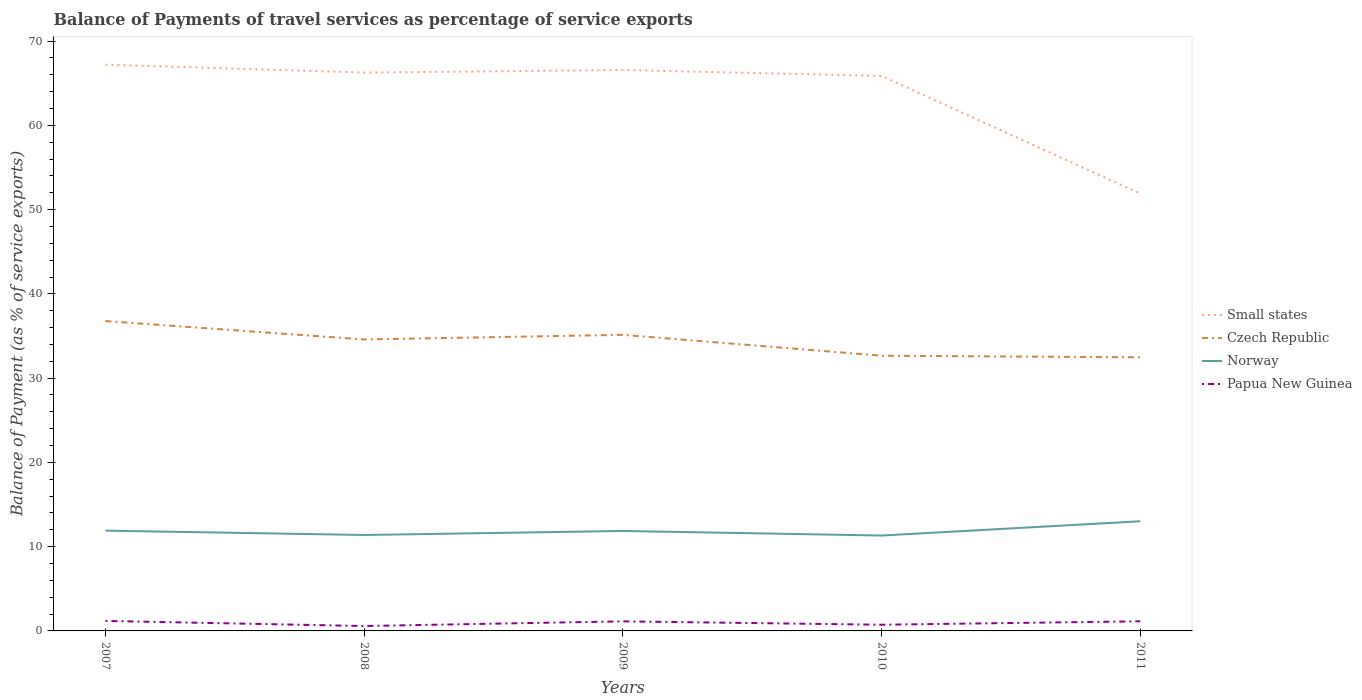Does the line corresponding to Czech Republic intersect with the line corresponding to Papua New Guinea?
Offer a very short reply. No. Across all years, what is the maximum balance of payments of travel services in Small states?
Provide a succinct answer. 51.89. In which year was the balance of payments of travel services in Small states maximum?
Your response must be concise. 2011. What is the total balance of payments of travel services in Norway in the graph?
Offer a very short reply. -1.7. What is the difference between the highest and the second highest balance of payments of travel services in Czech Republic?
Your response must be concise. 4.3. Is the balance of payments of travel services in Small states strictly greater than the balance of payments of travel services in Czech Republic over the years?
Keep it short and to the point. No. How many years are there in the graph?
Provide a short and direct response. 5. Does the graph contain grids?
Offer a very short reply. No. Where does the legend appear in the graph?
Keep it short and to the point. Center right. How many legend labels are there?
Provide a succinct answer. 4. What is the title of the graph?
Your answer should be very brief. Balance of Payments of travel services as percentage of service exports. Does "Macao" appear as one of the legend labels in the graph?
Your answer should be very brief. No. What is the label or title of the Y-axis?
Provide a short and direct response. Balance of Payment (as % of service exports). What is the Balance of Payment (as % of service exports) of Small states in 2007?
Make the answer very short. 67.21. What is the Balance of Payment (as % of service exports) of Czech Republic in 2007?
Offer a very short reply. 36.77. What is the Balance of Payment (as % of service exports) of Norway in 2007?
Make the answer very short. 11.9. What is the Balance of Payment (as % of service exports) in Papua New Guinea in 2007?
Ensure brevity in your answer.  1.19. What is the Balance of Payment (as % of service exports) in Small states in 2008?
Make the answer very short. 66.26. What is the Balance of Payment (as % of service exports) of Czech Republic in 2008?
Offer a very short reply. 34.59. What is the Balance of Payment (as % of service exports) of Norway in 2008?
Make the answer very short. 11.38. What is the Balance of Payment (as % of service exports) of Papua New Guinea in 2008?
Keep it short and to the point. 0.58. What is the Balance of Payment (as % of service exports) of Small states in 2009?
Your answer should be very brief. 66.57. What is the Balance of Payment (as % of service exports) in Czech Republic in 2009?
Your response must be concise. 35.14. What is the Balance of Payment (as % of service exports) of Norway in 2009?
Make the answer very short. 11.86. What is the Balance of Payment (as % of service exports) of Papua New Guinea in 2009?
Offer a very short reply. 1.14. What is the Balance of Payment (as % of service exports) in Small states in 2010?
Provide a short and direct response. 65.87. What is the Balance of Payment (as % of service exports) of Czech Republic in 2010?
Offer a terse response. 32.66. What is the Balance of Payment (as % of service exports) in Norway in 2010?
Offer a very short reply. 11.32. What is the Balance of Payment (as % of service exports) in Papua New Guinea in 2010?
Give a very brief answer. 0.73. What is the Balance of Payment (as % of service exports) of Small states in 2011?
Your answer should be very brief. 51.89. What is the Balance of Payment (as % of service exports) of Czech Republic in 2011?
Offer a terse response. 32.47. What is the Balance of Payment (as % of service exports) in Norway in 2011?
Your response must be concise. 13.01. What is the Balance of Payment (as % of service exports) in Papua New Guinea in 2011?
Provide a succinct answer. 1.14. Across all years, what is the maximum Balance of Payment (as % of service exports) of Small states?
Offer a terse response. 67.21. Across all years, what is the maximum Balance of Payment (as % of service exports) in Czech Republic?
Keep it short and to the point. 36.77. Across all years, what is the maximum Balance of Payment (as % of service exports) of Norway?
Ensure brevity in your answer.  13.01. Across all years, what is the maximum Balance of Payment (as % of service exports) in Papua New Guinea?
Offer a terse response. 1.19. Across all years, what is the minimum Balance of Payment (as % of service exports) of Small states?
Your answer should be compact. 51.89. Across all years, what is the minimum Balance of Payment (as % of service exports) of Czech Republic?
Offer a very short reply. 32.47. Across all years, what is the minimum Balance of Payment (as % of service exports) of Norway?
Provide a short and direct response. 11.32. Across all years, what is the minimum Balance of Payment (as % of service exports) in Papua New Guinea?
Keep it short and to the point. 0.58. What is the total Balance of Payment (as % of service exports) in Small states in the graph?
Provide a short and direct response. 317.8. What is the total Balance of Payment (as % of service exports) of Czech Republic in the graph?
Provide a short and direct response. 171.64. What is the total Balance of Payment (as % of service exports) of Norway in the graph?
Your answer should be compact. 59.49. What is the total Balance of Payment (as % of service exports) of Papua New Guinea in the graph?
Offer a very short reply. 4.78. What is the difference between the Balance of Payment (as % of service exports) in Small states in 2007 and that in 2008?
Ensure brevity in your answer.  0.94. What is the difference between the Balance of Payment (as % of service exports) in Czech Republic in 2007 and that in 2008?
Your answer should be compact. 2.18. What is the difference between the Balance of Payment (as % of service exports) of Norway in 2007 and that in 2008?
Keep it short and to the point. 0.52. What is the difference between the Balance of Payment (as % of service exports) of Papua New Guinea in 2007 and that in 2008?
Your answer should be very brief. 0.6. What is the difference between the Balance of Payment (as % of service exports) of Small states in 2007 and that in 2009?
Provide a succinct answer. 0.64. What is the difference between the Balance of Payment (as % of service exports) of Czech Republic in 2007 and that in 2009?
Give a very brief answer. 1.63. What is the difference between the Balance of Payment (as % of service exports) of Norway in 2007 and that in 2009?
Your answer should be compact. 0.04. What is the difference between the Balance of Payment (as % of service exports) in Papua New Guinea in 2007 and that in 2009?
Offer a terse response. 0.05. What is the difference between the Balance of Payment (as % of service exports) of Small states in 2007 and that in 2010?
Keep it short and to the point. 1.34. What is the difference between the Balance of Payment (as % of service exports) of Czech Republic in 2007 and that in 2010?
Offer a very short reply. 4.11. What is the difference between the Balance of Payment (as % of service exports) in Norway in 2007 and that in 2010?
Keep it short and to the point. 0.59. What is the difference between the Balance of Payment (as % of service exports) of Papua New Guinea in 2007 and that in 2010?
Make the answer very short. 0.45. What is the difference between the Balance of Payment (as % of service exports) of Small states in 2007 and that in 2011?
Provide a succinct answer. 15.31. What is the difference between the Balance of Payment (as % of service exports) of Czech Republic in 2007 and that in 2011?
Your answer should be very brief. 4.3. What is the difference between the Balance of Payment (as % of service exports) in Norway in 2007 and that in 2011?
Your response must be concise. -1.11. What is the difference between the Balance of Payment (as % of service exports) of Papua New Guinea in 2007 and that in 2011?
Offer a very short reply. 0.04. What is the difference between the Balance of Payment (as % of service exports) in Small states in 2008 and that in 2009?
Provide a short and direct response. -0.31. What is the difference between the Balance of Payment (as % of service exports) in Czech Republic in 2008 and that in 2009?
Give a very brief answer. -0.55. What is the difference between the Balance of Payment (as % of service exports) in Norway in 2008 and that in 2009?
Make the answer very short. -0.48. What is the difference between the Balance of Payment (as % of service exports) in Papua New Guinea in 2008 and that in 2009?
Offer a very short reply. -0.55. What is the difference between the Balance of Payment (as % of service exports) in Small states in 2008 and that in 2010?
Provide a short and direct response. 0.4. What is the difference between the Balance of Payment (as % of service exports) of Czech Republic in 2008 and that in 2010?
Your answer should be compact. 1.93. What is the difference between the Balance of Payment (as % of service exports) in Norway in 2008 and that in 2010?
Give a very brief answer. 0.07. What is the difference between the Balance of Payment (as % of service exports) of Papua New Guinea in 2008 and that in 2010?
Offer a terse response. -0.15. What is the difference between the Balance of Payment (as % of service exports) in Small states in 2008 and that in 2011?
Give a very brief answer. 14.37. What is the difference between the Balance of Payment (as % of service exports) in Czech Republic in 2008 and that in 2011?
Offer a terse response. 2.12. What is the difference between the Balance of Payment (as % of service exports) of Norway in 2008 and that in 2011?
Provide a short and direct response. -1.63. What is the difference between the Balance of Payment (as % of service exports) of Papua New Guinea in 2008 and that in 2011?
Provide a short and direct response. -0.56. What is the difference between the Balance of Payment (as % of service exports) of Small states in 2009 and that in 2010?
Your answer should be very brief. 0.71. What is the difference between the Balance of Payment (as % of service exports) of Czech Republic in 2009 and that in 2010?
Make the answer very short. 2.48. What is the difference between the Balance of Payment (as % of service exports) of Norway in 2009 and that in 2010?
Offer a terse response. 0.54. What is the difference between the Balance of Payment (as % of service exports) of Papua New Guinea in 2009 and that in 2010?
Ensure brevity in your answer.  0.4. What is the difference between the Balance of Payment (as % of service exports) of Small states in 2009 and that in 2011?
Make the answer very short. 14.68. What is the difference between the Balance of Payment (as % of service exports) of Czech Republic in 2009 and that in 2011?
Provide a succinct answer. 2.67. What is the difference between the Balance of Payment (as % of service exports) of Norway in 2009 and that in 2011?
Provide a succinct answer. -1.15. What is the difference between the Balance of Payment (as % of service exports) in Papua New Guinea in 2009 and that in 2011?
Offer a terse response. -0.01. What is the difference between the Balance of Payment (as % of service exports) in Small states in 2010 and that in 2011?
Keep it short and to the point. 13.97. What is the difference between the Balance of Payment (as % of service exports) in Czech Republic in 2010 and that in 2011?
Give a very brief answer. 0.19. What is the difference between the Balance of Payment (as % of service exports) of Norway in 2010 and that in 2011?
Offer a terse response. -1.7. What is the difference between the Balance of Payment (as % of service exports) in Papua New Guinea in 2010 and that in 2011?
Offer a very short reply. -0.41. What is the difference between the Balance of Payment (as % of service exports) in Small states in 2007 and the Balance of Payment (as % of service exports) in Czech Republic in 2008?
Give a very brief answer. 32.62. What is the difference between the Balance of Payment (as % of service exports) of Small states in 2007 and the Balance of Payment (as % of service exports) of Norway in 2008?
Make the answer very short. 55.82. What is the difference between the Balance of Payment (as % of service exports) of Small states in 2007 and the Balance of Payment (as % of service exports) of Papua New Guinea in 2008?
Your response must be concise. 66.62. What is the difference between the Balance of Payment (as % of service exports) of Czech Republic in 2007 and the Balance of Payment (as % of service exports) of Norway in 2008?
Make the answer very short. 25.39. What is the difference between the Balance of Payment (as % of service exports) in Czech Republic in 2007 and the Balance of Payment (as % of service exports) in Papua New Guinea in 2008?
Ensure brevity in your answer.  36.19. What is the difference between the Balance of Payment (as % of service exports) of Norway in 2007 and the Balance of Payment (as % of service exports) of Papua New Guinea in 2008?
Give a very brief answer. 11.32. What is the difference between the Balance of Payment (as % of service exports) of Small states in 2007 and the Balance of Payment (as % of service exports) of Czech Republic in 2009?
Offer a very short reply. 32.07. What is the difference between the Balance of Payment (as % of service exports) of Small states in 2007 and the Balance of Payment (as % of service exports) of Norway in 2009?
Your response must be concise. 55.34. What is the difference between the Balance of Payment (as % of service exports) of Small states in 2007 and the Balance of Payment (as % of service exports) of Papua New Guinea in 2009?
Provide a succinct answer. 66.07. What is the difference between the Balance of Payment (as % of service exports) in Czech Republic in 2007 and the Balance of Payment (as % of service exports) in Norway in 2009?
Give a very brief answer. 24.91. What is the difference between the Balance of Payment (as % of service exports) in Czech Republic in 2007 and the Balance of Payment (as % of service exports) in Papua New Guinea in 2009?
Your response must be concise. 35.64. What is the difference between the Balance of Payment (as % of service exports) of Norway in 2007 and the Balance of Payment (as % of service exports) of Papua New Guinea in 2009?
Offer a very short reply. 10.77. What is the difference between the Balance of Payment (as % of service exports) of Small states in 2007 and the Balance of Payment (as % of service exports) of Czech Republic in 2010?
Offer a very short reply. 34.54. What is the difference between the Balance of Payment (as % of service exports) in Small states in 2007 and the Balance of Payment (as % of service exports) in Norway in 2010?
Your answer should be very brief. 55.89. What is the difference between the Balance of Payment (as % of service exports) in Small states in 2007 and the Balance of Payment (as % of service exports) in Papua New Guinea in 2010?
Provide a short and direct response. 66.47. What is the difference between the Balance of Payment (as % of service exports) in Czech Republic in 2007 and the Balance of Payment (as % of service exports) in Norway in 2010?
Offer a very short reply. 25.46. What is the difference between the Balance of Payment (as % of service exports) in Czech Republic in 2007 and the Balance of Payment (as % of service exports) in Papua New Guinea in 2010?
Provide a succinct answer. 36.04. What is the difference between the Balance of Payment (as % of service exports) in Norway in 2007 and the Balance of Payment (as % of service exports) in Papua New Guinea in 2010?
Your answer should be very brief. 11.17. What is the difference between the Balance of Payment (as % of service exports) in Small states in 2007 and the Balance of Payment (as % of service exports) in Czech Republic in 2011?
Provide a short and direct response. 34.73. What is the difference between the Balance of Payment (as % of service exports) of Small states in 2007 and the Balance of Payment (as % of service exports) of Norway in 2011?
Your answer should be very brief. 54.19. What is the difference between the Balance of Payment (as % of service exports) in Small states in 2007 and the Balance of Payment (as % of service exports) in Papua New Guinea in 2011?
Offer a very short reply. 66.06. What is the difference between the Balance of Payment (as % of service exports) in Czech Republic in 2007 and the Balance of Payment (as % of service exports) in Norway in 2011?
Your answer should be very brief. 23.76. What is the difference between the Balance of Payment (as % of service exports) in Czech Republic in 2007 and the Balance of Payment (as % of service exports) in Papua New Guinea in 2011?
Offer a very short reply. 35.63. What is the difference between the Balance of Payment (as % of service exports) in Norway in 2007 and the Balance of Payment (as % of service exports) in Papua New Guinea in 2011?
Your response must be concise. 10.76. What is the difference between the Balance of Payment (as % of service exports) in Small states in 2008 and the Balance of Payment (as % of service exports) in Czech Republic in 2009?
Your response must be concise. 31.12. What is the difference between the Balance of Payment (as % of service exports) of Small states in 2008 and the Balance of Payment (as % of service exports) of Norway in 2009?
Provide a succinct answer. 54.4. What is the difference between the Balance of Payment (as % of service exports) of Small states in 2008 and the Balance of Payment (as % of service exports) of Papua New Guinea in 2009?
Your answer should be very brief. 65.13. What is the difference between the Balance of Payment (as % of service exports) of Czech Republic in 2008 and the Balance of Payment (as % of service exports) of Norway in 2009?
Your answer should be very brief. 22.73. What is the difference between the Balance of Payment (as % of service exports) in Czech Republic in 2008 and the Balance of Payment (as % of service exports) in Papua New Guinea in 2009?
Keep it short and to the point. 33.46. What is the difference between the Balance of Payment (as % of service exports) in Norway in 2008 and the Balance of Payment (as % of service exports) in Papua New Guinea in 2009?
Your answer should be compact. 10.25. What is the difference between the Balance of Payment (as % of service exports) in Small states in 2008 and the Balance of Payment (as % of service exports) in Czech Republic in 2010?
Offer a terse response. 33.6. What is the difference between the Balance of Payment (as % of service exports) in Small states in 2008 and the Balance of Payment (as % of service exports) in Norway in 2010?
Make the answer very short. 54.94. What is the difference between the Balance of Payment (as % of service exports) in Small states in 2008 and the Balance of Payment (as % of service exports) in Papua New Guinea in 2010?
Provide a short and direct response. 65.53. What is the difference between the Balance of Payment (as % of service exports) in Czech Republic in 2008 and the Balance of Payment (as % of service exports) in Norway in 2010?
Offer a very short reply. 23.27. What is the difference between the Balance of Payment (as % of service exports) in Czech Republic in 2008 and the Balance of Payment (as % of service exports) in Papua New Guinea in 2010?
Your answer should be very brief. 33.86. What is the difference between the Balance of Payment (as % of service exports) in Norway in 2008 and the Balance of Payment (as % of service exports) in Papua New Guinea in 2010?
Your response must be concise. 10.65. What is the difference between the Balance of Payment (as % of service exports) in Small states in 2008 and the Balance of Payment (as % of service exports) in Czech Republic in 2011?
Give a very brief answer. 33.79. What is the difference between the Balance of Payment (as % of service exports) of Small states in 2008 and the Balance of Payment (as % of service exports) of Norway in 2011?
Ensure brevity in your answer.  53.25. What is the difference between the Balance of Payment (as % of service exports) in Small states in 2008 and the Balance of Payment (as % of service exports) in Papua New Guinea in 2011?
Your answer should be very brief. 65.12. What is the difference between the Balance of Payment (as % of service exports) in Czech Republic in 2008 and the Balance of Payment (as % of service exports) in Norway in 2011?
Offer a terse response. 21.58. What is the difference between the Balance of Payment (as % of service exports) in Czech Republic in 2008 and the Balance of Payment (as % of service exports) in Papua New Guinea in 2011?
Your answer should be compact. 33.45. What is the difference between the Balance of Payment (as % of service exports) in Norway in 2008 and the Balance of Payment (as % of service exports) in Papua New Guinea in 2011?
Ensure brevity in your answer.  10.24. What is the difference between the Balance of Payment (as % of service exports) of Small states in 2009 and the Balance of Payment (as % of service exports) of Czech Republic in 2010?
Provide a succinct answer. 33.91. What is the difference between the Balance of Payment (as % of service exports) of Small states in 2009 and the Balance of Payment (as % of service exports) of Norway in 2010?
Offer a terse response. 55.25. What is the difference between the Balance of Payment (as % of service exports) in Small states in 2009 and the Balance of Payment (as % of service exports) in Papua New Guinea in 2010?
Give a very brief answer. 65.84. What is the difference between the Balance of Payment (as % of service exports) in Czech Republic in 2009 and the Balance of Payment (as % of service exports) in Norway in 2010?
Your answer should be compact. 23.82. What is the difference between the Balance of Payment (as % of service exports) of Czech Republic in 2009 and the Balance of Payment (as % of service exports) of Papua New Guinea in 2010?
Your answer should be very brief. 34.41. What is the difference between the Balance of Payment (as % of service exports) in Norway in 2009 and the Balance of Payment (as % of service exports) in Papua New Guinea in 2010?
Ensure brevity in your answer.  11.13. What is the difference between the Balance of Payment (as % of service exports) of Small states in 2009 and the Balance of Payment (as % of service exports) of Czech Republic in 2011?
Keep it short and to the point. 34.1. What is the difference between the Balance of Payment (as % of service exports) in Small states in 2009 and the Balance of Payment (as % of service exports) in Norway in 2011?
Make the answer very short. 53.56. What is the difference between the Balance of Payment (as % of service exports) in Small states in 2009 and the Balance of Payment (as % of service exports) in Papua New Guinea in 2011?
Your answer should be compact. 65.43. What is the difference between the Balance of Payment (as % of service exports) of Czech Republic in 2009 and the Balance of Payment (as % of service exports) of Norway in 2011?
Your answer should be very brief. 22.13. What is the difference between the Balance of Payment (as % of service exports) of Czech Republic in 2009 and the Balance of Payment (as % of service exports) of Papua New Guinea in 2011?
Ensure brevity in your answer.  34. What is the difference between the Balance of Payment (as % of service exports) of Norway in 2009 and the Balance of Payment (as % of service exports) of Papua New Guinea in 2011?
Your answer should be compact. 10.72. What is the difference between the Balance of Payment (as % of service exports) of Small states in 2010 and the Balance of Payment (as % of service exports) of Czech Republic in 2011?
Your response must be concise. 33.39. What is the difference between the Balance of Payment (as % of service exports) in Small states in 2010 and the Balance of Payment (as % of service exports) in Norway in 2011?
Provide a succinct answer. 52.85. What is the difference between the Balance of Payment (as % of service exports) of Small states in 2010 and the Balance of Payment (as % of service exports) of Papua New Guinea in 2011?
Ensure brevity in your answer.  64.72. What is the difference between the Balance of Payment (as % of service exports) of Czech Republic in 2010 and the Balance of Payment (as % of service exports) of Norway in 2011?
Keep it short and to the point. 19.65. What is the difference between the Balance of Payment (as % of service exports) of Czech Republic in 2010 and the Balance of Payment (as % of service exports) of Papua New Guinea in 2011?
Keep it short and to the point. 31.52. What is the difference between the Balance of Payment (as % of service exports) of Norway in 2010 and the Balance of Payment (as % of service exports) of Papua New Guinea in 2011?
Make the answer very short. 10.18. What is the average Balance of Payment (as % of service exports) of Small states per year?
Provide a short and direct response. 63.56. What is the average Balance of Payment (as % of service exports) in Czech Republic per year?
Your response must be concise. 34.33. What is the average Balance of Payment (as % of service exports) in Norway per year?
Give a very brief answer. 11.9. What is the average Balance of Payment (as % of service exports) of Papua New Guinea per year?
Your response must be concise. 0.96. In the year 2007, what is the difference between the Balance of Payment (as % of service exports) of Small states and Balance of Payment (as % of service exports) of Czech Republic?
Keep it short and to the point. 30.43. In the year 2007, what is the difference between the Balance of Payment (as % of service exports) of Small states and Balance of Payment (as % of service exports) of Norway?
Provide a succinct answer. 55.3. In the year 2007, what is the difference between the Balance of Payment (as % of service exports) of Small states and Balance of Payment (as % of service exports) of Papua New Guinea?
Ensure brevity in your answer.  66.02. In the year 2007, what is the difference between the Balance of Payment (as % of service exports) in Czech Republic and Balance of Payment (as % of service exports) in Norway?
Offer a very short reply. 24.87. In the year 2007, what is the difference between the Balance of Payment (as % of service exports) in Czech Republic and Balance of Payment (as % of service exports) in Papua New Guinea?
Your response must be concise. 35.59. In the year 2007, what is the difference between the Balance of Payment (as % of service exports) in Norway and Balance of Payment (as % of service exports) in Papua New Guinea?
Give a very brief answer. 10.72. In the year 2008, what is the difference between the Balance of Payment (as % of service exports) of Small states and Balance of Payment (as % of service exports) of Czech Republic?
Provide a short and direct response. 31.67. In the year 2008, what is the difference between the Balance of Payment (as % of service exports) in Small states and Balance of Payment (as % of service exports) in Norway?
Provide a succinct answer. 54.88. In the year 2008, what is the difference between the Balance of Payment (as % of service exports) in Small states and Balance of Payment (as % of service exports) in Papua New Guinea?
Your answer should be very brief. 65.68. In the year 2008, what is the difference between the Balance of Payment (as % of service exports) in Czech Republic and Balance of Payment (as % of service exports) in Norway?
Provide a succinct answer. 23.21. In the year 2008, what is the difference between the Balance of Payment (as % of service exports) in Czech Republic and Balance of Payment (as % of service exports) in Papua New Guinea?
Ensure brevity in your answer.  34.01. In the year 2008, what is the difference between the Balance of Payment (as % of service exports) in Norway and Balance of Payment (as % of service exports) in Papua New Guinea?
Offer a terse response. 10.8. In the year 2009, what is the difference between the Balance of Payment (as % of service exports) of Small states and Balance of Payment (as % of service exports) of Czech Republic?
Your answer should be very brief. 31.43. In the year 2009, what is the difference between the Balance of Payment (as % of service exports) in Small states and Balance of Payment (as % of service exports) in Norway?
Offer a very short reply. 54.71. In the year 2009, what is the difference between the Balance of Payment (as % of service exports) of Small states and Balance of Payment (as % of service exports) of Papua New Guinea?
Offer a terse response. 65.44. In the year 2009, what is the difference between the Balance of Payment (as % of service exports) in Czech Republic and Balance of Payment (as % of service exports) in Norway?
Ensure brevity in your answer.  23.28. In the year 2009, what is the difference between the Balance of Payment (as % of service exports) of Czech Republic and Balance of Payment (as % of service exports) of Papua New Guinea?
Offer a very short reply. 34. In the year 2009, what is the difference between the Balance of Payment (as % of service exports) of Norway and Balance of Payment (as % of service exports) of Papua New Guinea?
Your answer should be compact. 10.73. In the year 2010, what is the difference between the Balance of Payment (as % of service exports) of Small states and Balance of Payment (as % of service exports) of Czech Republic?
Your answer should be compact. 33.2. In the year 2010, what is the difference between the Balance of Payment (as % of service exports) of Small states and Balance of Payment (as % of service exports) of Norway?
Your answer should be very brief. 54.55. In the year 2010, what is the difference between the Balance of Payment (as % of service exports) in Small states and Balance of Payment (as % of service exports) in Papua New Guinea?
Provide a succinct answer. 65.13. In the year 2010, what is the difference between the Balance of Payment (as % of service exports) of Czech Republic and Balance of Payment (as % of service exports) of Norway?
Ensure brevity in your answer.  21.34. In the year 2010, what is the difference between the Balance of Payment (as % of service exports) of Czech Republic and Balance of Payment (as % of service exports) of Papua New Guinea?
Keep it short and to the point. 31.93. In the year 2010, what is the difference between the Balance of Payment (as % of service exports) of Norway and Balance of Payment (as % of service exports) of Papua New Guinea?
Your response must be concise. 10.58. In the year 2011, what is the difference between the Balance of Payment (as % of service exports) of Small states and Balance of Payment (as % of service exports) of Czech Republic?
Your response must be concise. 19.42. In the year 2011, what is the difference between the Balance of Payment (as % of service exports) of Small states and Balance of Payment (as % of service exports) of Norway?
Offer a terse response. 38.88. In the year 2011, what is the difference between the Balance of Payment (as % of service exports) in Small states and Balance of Payment (as % of service exports) in Papua New Guinea?
Ensure brevity in your answer.  50.75. In the year 2011, what is the difference between the Balance of Payment (as % of service exports) of Czech Republic and Balance of Payment (as % of service exports) of Norway?
Your answer should be compact. 19.46. In the year 2011, what is the difference between the Balance of Payment (as % of service exports) in Czech Republic and Balance of Payment (as % of service exports) in Papua New Guinea?
Offer a very short reply. 31.33. In the year 2011, what is the difference between the Balance of Payment (as % of service exports) of Norway and Balance of Payment (as % of service exports) of Papua New Guinea?
Keep it short and to the point. 11.87. What is the ratio of the Balance of Payment (as % of service exports) in Small states in 2007 to that in 2008?
Keep it short and to the point. 1.01. What is the ratio of the Balance of Payment (as % of service exports) of Czech Republic in 2007 to that in 2008?
Offer a very short reply. 1.06. What is the ratio of the Balance of Payment (as % of service exports) of Norway in 2007 to that in 2008?
Your response must be concise. 1.05. What is the ratio of the Balance of Payment (as % of service exports) of Papua New Guinea in 2007 to that in 2008?
Provide a short and direct response. 2.04. What is the ratio of the Balance of Payment (as % of service exports) of Small states in 2007 to that in 2009?
Give a very brief answer. 1.01. What is the ratio of the Balance of Payment (as % of service exports) of Czech Republic in 2007 to that in 2009?
Provide a short and direct response. 1.05. What is the ratio of the Balance of Payment (as % of service exports) of Papua New Guinea in 2007 to that in 2009?
Your answer should be compact. 1.04. What is the ratio of the Balance of Payment (as % of service exports) of Small states in 2007 to that in 2010?
Your answer should be very brief. 1.02. What is the ratio of the Balance of Payment (as % of service exports) in Czech Republic in 2007 to that in 2010?
Your answer should be compact. 1.13. What is the ratio of the Balance of Payment (as % of service exports) of Norway in 2007 to that in 2010?
Your response must be concise. 1.05. What is the ratio of the Balance of Payment (as % of service exports) in Papua New Guinea in 2007 to that in 2010?
Keep it short and to the point. 1.61. What is the ratio of the Balance of Payment (as % of service exports) in Small states in 2007 to that in 2011?
Provide a short and direct response. 1.3. What is the ratio of the Balance of Payment (as % of service exports) of Czech Republic in 2007 to that in 2011?
Ensure brevity in your answer.  1.13. What is the ratio of the Balance of Payment (as % of service exports) in Norway in 2007 to that in 2011?
Your answer should be compact. 0.91. What is the ratio of the Balance of Payment (as % of service exports) of Papua New Guinea in 2007 to that in 2011?
Make the answer very short. 1.04. What is the ratio of the Balance of Payment (as % of service exports) in Small states in 2008 to that in 2009?
Make the answer very short. 1. What is the ratio of the Balance of Payment (as % of service exports) of Czech Republic in 2008 to that in 2009?
Your answer should be very brief. 0.98. What is the ratio of the Balance of Payment (as % of service exports) of Norway in 2008 to that in 2009?
Your response must be concise. 0.96. What is the ratio of the Balance of Payment (as % of service exports) in Papua New Guinea in 2008 to that in 2009?
Offer a very short reply. 0.51. What is the ratio of the Balance of Payment (as % of service exports) of Czech Republic in 2008 to that in 2010?
Your answer should be very brief. 1.06. What is the ratio of the Balance of Payment (as % of service exports) in Papua New Guinea in 2008 to that in 2010?
Your answer should be compact. 0.79. What is the ratio of the Balance of Payment (as % of service exports) of Small states in 2008 to that in 2011?
Your answer should be very brief. 1.28. What is the ratio of the Balance of Payment (as % of service exports) in Czech Republic in 2008 to that in 2011?
Keep it short and to the point. 1.07. What is the ratio of the Balance of Payment (as % of service exports) of Norway in 2008 to that in 2011?
Ensure brevity in your answer.  0.87. What is the ratio of the Balance of Payment (as % of service exports) in Papua New Guinea in 2008 to that in 2011?
Your answer should be compact. 0.51. What is the ratio of the Balance of Payment (as % of service exports) of Small states in 2009 to that in 2010?
Give a very brief answer. 1.01. What is the ratio of the Balance of Payment (as % of service exports) of Czech Republic in 2009 to that in 2010?
Make the answer very short. 1.08. What is the ratio of the Balance of Payment (as % of service exports) of Norway in 2009 to that in 2010?
Your answer should be compact. 1.05. What is the ratio of the Balance of Payment (as % of service exports) of Papua New Guinea in 2009 to that in 2010?
Keep it short and to the point. 1.55. What is the ratio of the Balance of Payment (as % of service exports) of Small states in 2009 to that in 2011?
Give a very brief answer. 1.28. What is the ratio of the Balance of Payment (as % of service exports) of Czech Republic in 2009 to that in 2011?
Provide a short and direct response. 1.08. What is the ratio of the Balance of Payment (as % of service exports) in Norway in 2009 to that in 2011?
Offer a very short reply. 0.91. What is the ratio of the Balance of Payment (as % of service exports) of Papua New Guinea in 2009 to that in 2011?
Your response must be concise. 0.99. What is the ratio of the Balance of Payment (as % of service exports) in Small states in 2010 to that in 2011?
Make the answer very short. 1.27. What is the ratio of the Balance of Payment (as % of service exports) of Norway in 2010 to that in 2011?
Make the answer very short. 0.87. What is the ratio of the Balance of Payment (as % of service exports) in Papua New Guinea in 2010 to that in 2011?
Give a very brief answer. 0.64. What is the difference between the highest and the second highest Balance of Payment (as % of service exports) of Small states?
Offer a very short reply. 0.64. What is the difference between the highest and the second highest Balance of Payment (as % of service exports) in Czech Republic?
Provide a short and direct response. 1.63. What is the difference between the highest and the second highest Balance of Payment (as % of service exports) in Norway?
Your response must be concise. 1.11. What is the difference between the highest and the second highest Balance of Payment (as % of service exports) of Papua New Guinea?
Ensure brevity in your answer.  0.04. What is the difference between the highest and the lowest Balance of Payment (as % of service exports) in Small states?
Make the answer very short. 15.31. What is the difference between the highest and the lowest Balance of Payment (as % of service exports) in Czech Republic?
Make the answer very short. 4.3. What is the difference between the highest and the lowest Balance of Payment (as % of service exports) of Norway?
Provide a succinct answer. 1.7. What is the difference between the highest and the lowest Balance of Payment (as % of service exports) in Papua New Guinea?
Your response must be concise. 0.6. 